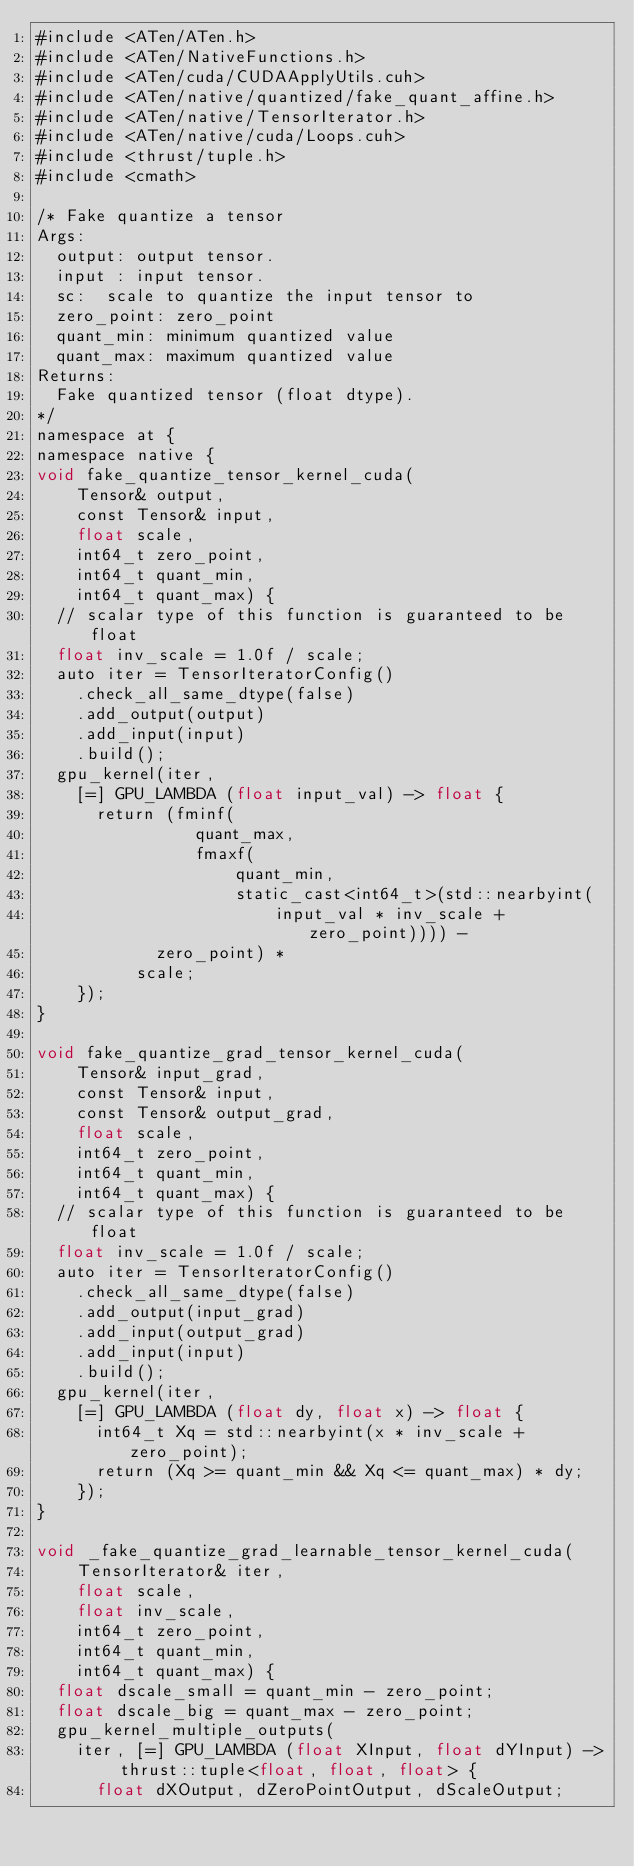<code> <loc_0><loc_0><loc_500><loc_500><_Cuda_>#include <ATen/ATen.h>
#include <ATen/NativeFunctions.h>
#include <ATen/cuda/CUDAApplyUtils.cuh>
#include <ATen/native/quantized/fake_quant_affine.h>
#include <ATen/native/TensorIterator.h>
#include <ATen/native/cuda/Loops.cuh>
#include <thrust/tuple.h>
#include <cmath>

/* Fake quantize a tensor
Args:
  output: output tensor.
  input : input tensor.
  sc:  scale to quantize the input tensor to
  zero_point: zero_point
  quant_min: minimum quantized value
  quant_max: maximum quantized value
Returns:
  Fake quantized tensor (float dtype).
*/
namespace at {
namespace native {
void fake_quantize_tensor_kernel_cuda(
    Tensor& output,
    const Tensor& input,
    float scale,
    int64_t zero_point,
    int64_t quant_min,
    int64_t quant_max) {
  // scalar type of this function is guaranteed to be float
  float inv_scale = 1.0f / scale;
  auto iter = TensorIteratorConfig()
    .check_all_same_dtype(false)
    .add_output(output)
    .add_input(input)
    .build();
  gpu_kernel(iter,
    [=] GPU_LAMBDA (float input_val) -> float {
      return (fminf(
                quant_max,
                fmaxf(
                    quant_min,
                    static_cast<int64_t>(std::nearbyint(
                        input_val * inv_scale + zero_point)))) -
            zero_point) *
          scale;
    });
}

void fake_quantize_grad_tensor_kernel_cuda(
    Tensor& input_grad,
    const Tensor& input,
    const Tensor& output_grad,
    float scale,
    int64_t zero_point,
    int64_t quant_min,
    int64_t quant_max) {
  // scalar type of this function is guaranteed to be float
  float inv_scale = 1.0f / scale;
  auto iter = TensorIteratorConfig()
    .check_all_same_dtype(false)
    .add_output(input_grad)
    .add_input(output_grad)
    .add_input(input)
    .build();
  gpu_kernel(iter,
    [=] GPU_LAMBDA (float dy, float x) -> float {
      int64_t Xq = std::nearbyint(x * inv_scale + zero_point);
      return (Xq >= quant_min && Xq <= quant_max) * dy;
    });
}

void _fake_quantize_grad_learnable_tensor_kernel_cuda(
    TensorIterator& iter,
    float scale,
    float inv_scale,
    int64_t zero_point,
    int64_t quant_min,
    int64_t quant_max) {
  float dscale_small = quant_min - zero_point;
  float dscale_big = quant_max - zero_point;
  gpu_kernel_multiple_outputs(
    iter, [=] GPU_LAMBDA (float XInput, float dYInput) -> thrust::tuple<float, float, float> {
      float dXOutput, dZeroPointOutput, dScaleOutput;</code> 